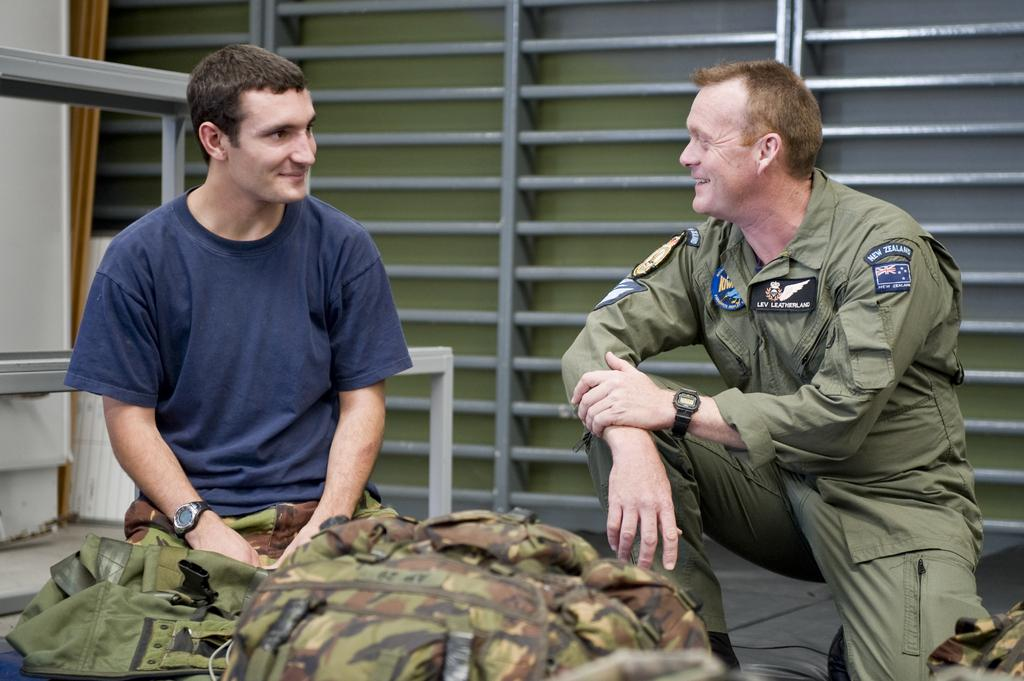How many people are in the image? There are two persons in the image. What are the persons doing in the image? The persons are sitting and smiling at each other. What is in front of the persons? There is a camouflage bag in front of the persons. What is visible behind the persons? There is a metal structure behind the persons. What grade did the goat receive on its report card in the image? There is no goat present in the image, and therefore no report card or grade can be observed. 